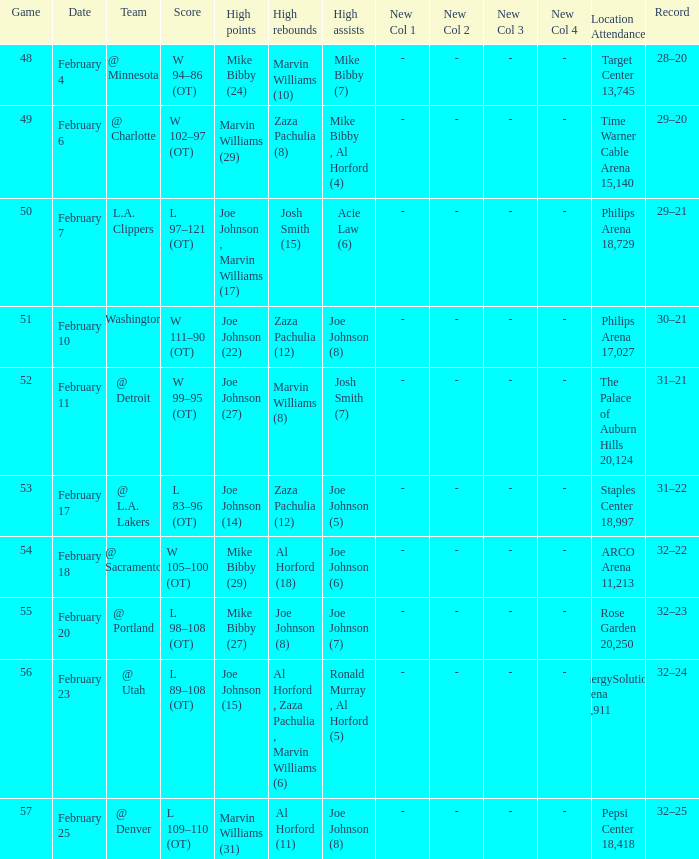Who made high assists on february 4 Mike Bibby (7). 